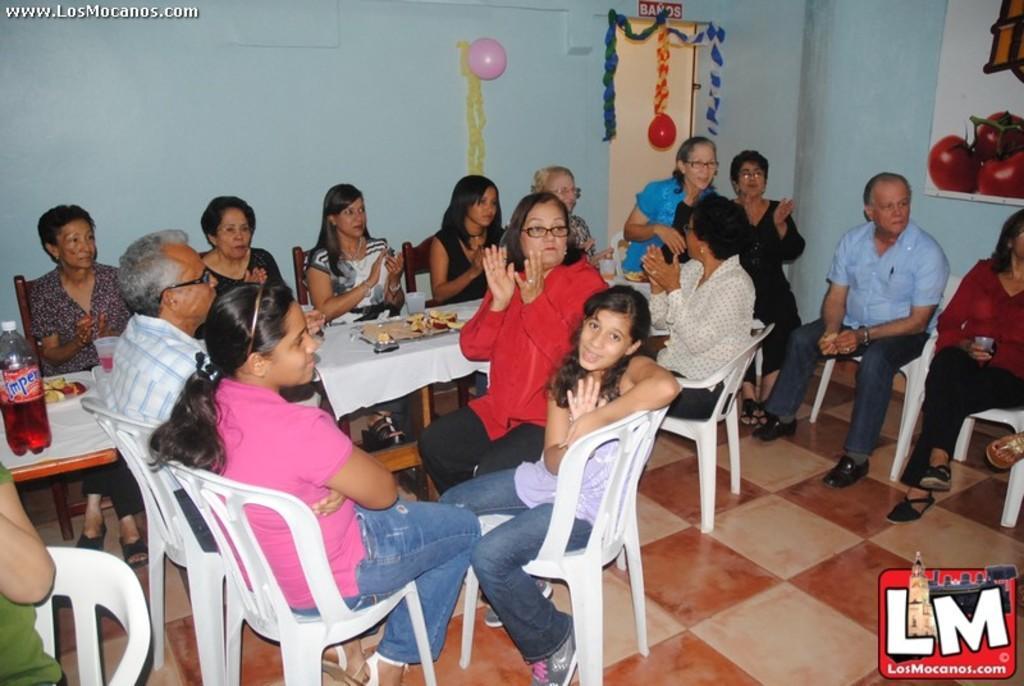Can you describe this image briefly? As we can see in the image there is a wall, balloon, few people sitting on chairs and there is a table. On table there is a plate and bottle. 